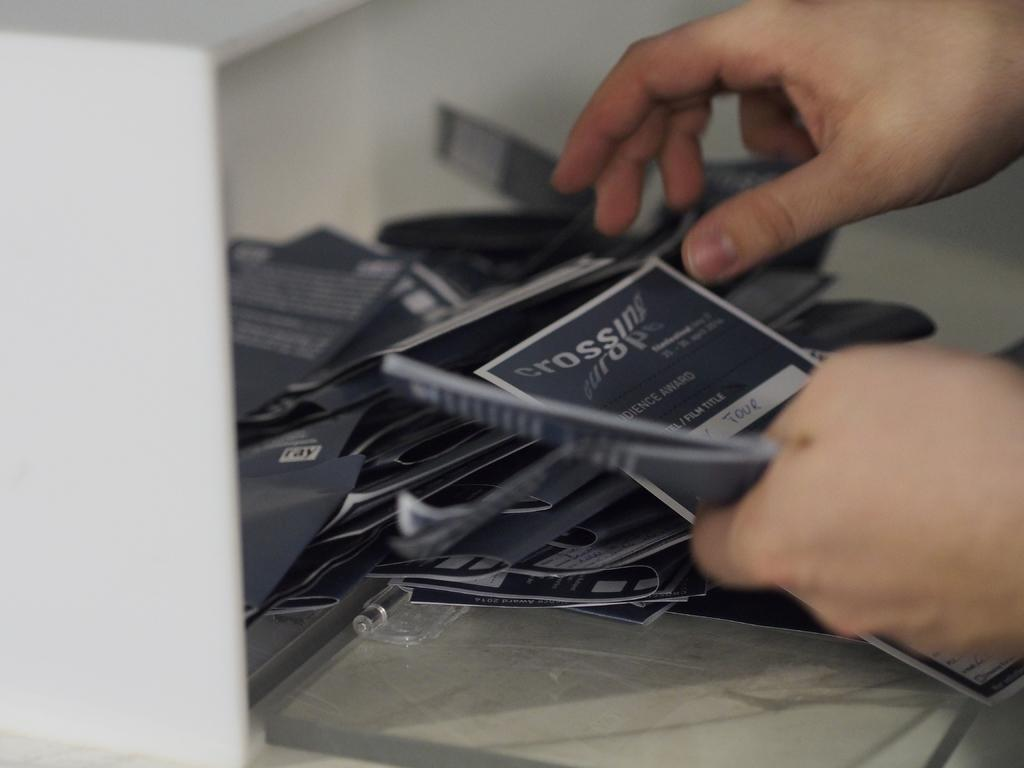What body part is visible in the image? There are hands visible in the image. To whom do the hands belong? The hands belong to a person. What is in the middle of the image? There are cards in the middle of the image. Can you describe the background of the image? The background of the image is blurred. What type of pets can be seen in the image? There are no pets visible in the image. What sound is being made by the cards in the image? The cards in the image are not making any sound. 